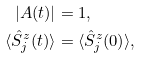<formula> <loc_0><loc_0><loc_500><loc_500>| A ( t ) | & = 1 , \\ \langle \hat { S } ^ { z } _ { j } ( t ) \rangle & = \langle \hat { S } ^ { z } _ { j } ( 0 ) \rangle ,</formula> 